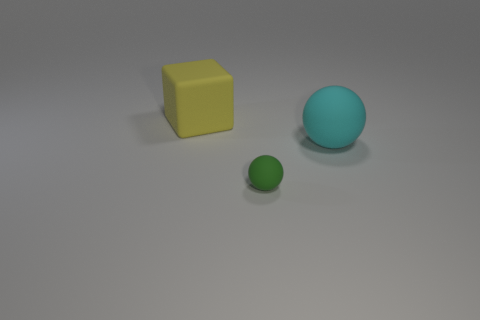Add 2 large yellow blocks. How many objects exist? 5 Subtract all green spheres. How many spheres are left? 1 Subtract all tiny purple cubes. Subtract all large yellow matte blocks. How many objects are left? 2 Add 3 balls. How many balls are left? 5 Add 1 blocks. How many blocks exist? 2 Subtract 0 blue cylinders. How many objects are left? 3 Subtract all blocks. How many objects are left? 2 Subtract 2 balls. How many balls are left? 0 Subtract all purple cubes. Subtract all gray spheres. How many cubes are left? 1 